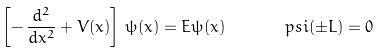Convert formula to latex. <formula><loc_0><loc_0><loc_500><loc_500>\left [ - \, \frac { d ^ { 2 } } { d x ^ { 2 } } + V ( x ) \right ] \, \psi ( x ) = E \psi ( x ) \, \quad \ \ \ p s i ( \pm L ) = 0</formula> 